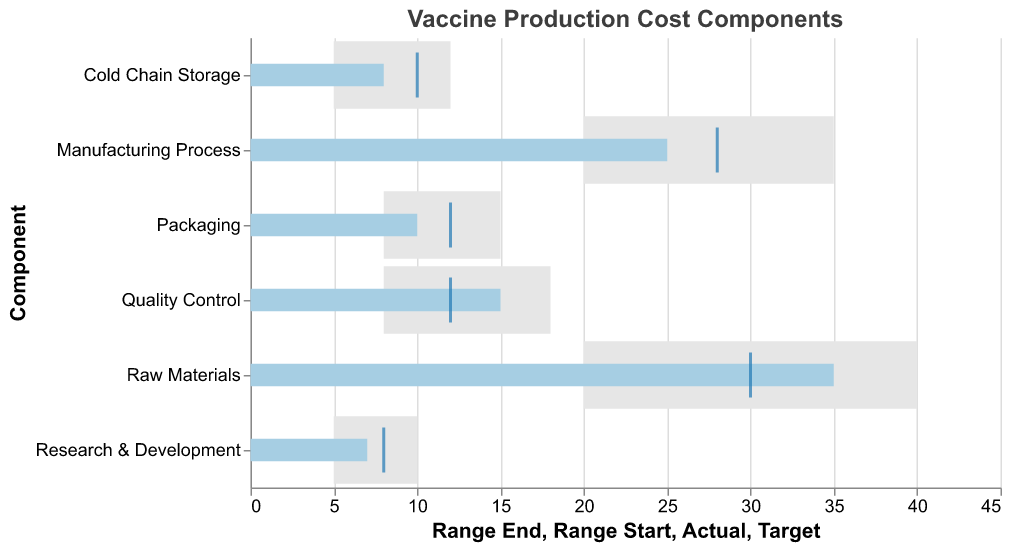What's the title of the figure? The title is displayed at the top of the chart, written in bold and is the most prominent text.
Answer: Vaccine Production Cost Components What is the actual cost percentage attributed to Raw Materials? The bar corresponding to "Raw Materials" in the chart displays the actual value within the bar's width.
Answer: 35% Which component's actual percentage cost is the closest to its target? By observing the chart, the tick marks (targets) can be compared to the bars (actuals).
Answer: Research & Development Which component has the highest actual percentage cost? Examine the lengths of the light blue bars representing the actual costs for each component.
Answer: Raw Materials How many components have an actual percentage cost exceeding their target? Compare the actual percentage bars with the target tick marks for each component and count the occurrences where the bars exceed the ticks.
Answer: 3 (Raw Materials, Quality Control, and Packaging) What's the difference between the actual and target values for the Manufacturing Process component? Subtract the target value from the actual value for the Manufacturing Process component.
Answer: -3% (25% - 28%) Which components have actual costs falling within their defined range? For each component, check if the actual percentage bar intersects with the range defined by the gray area.
Answer: Raw Materials, Manufacturing Process, Quality Control, Cold Chain Storage, Research & Development In which components has the actual cost fallen short of the target? Identify components where the actual value bar is shorter than the target tick mark.
Answer: Manufacturing Process, Packaging, Cold Chain Storage, Research & Development Compare the actual costs of Raw Materials and Manufacturing Process. Which one is greater, and by how much? Calculate the difference between the actual values of Raw Materials (35%) and Manufacturing Process (25%).
Answer: Raw Materials is greater by 10% What's the average target percentage across all components? Sum all target percentages and divide by the number of components (30 + 28 + 12 + 12 + 10 + 8) / 6 = 16
Answer: 16% 